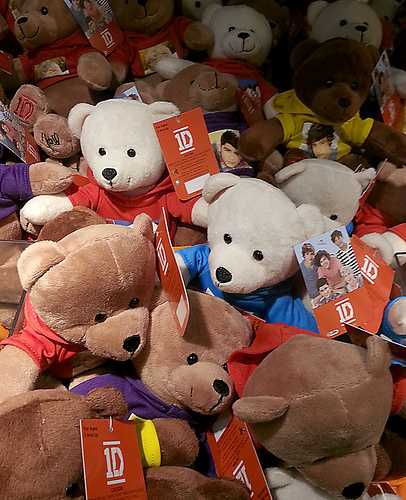<image>
Can you confirm if the tag is in front of the bear? Yes. The tag is positioned in front of the bear, appearing closer to the camera viewpoint. 